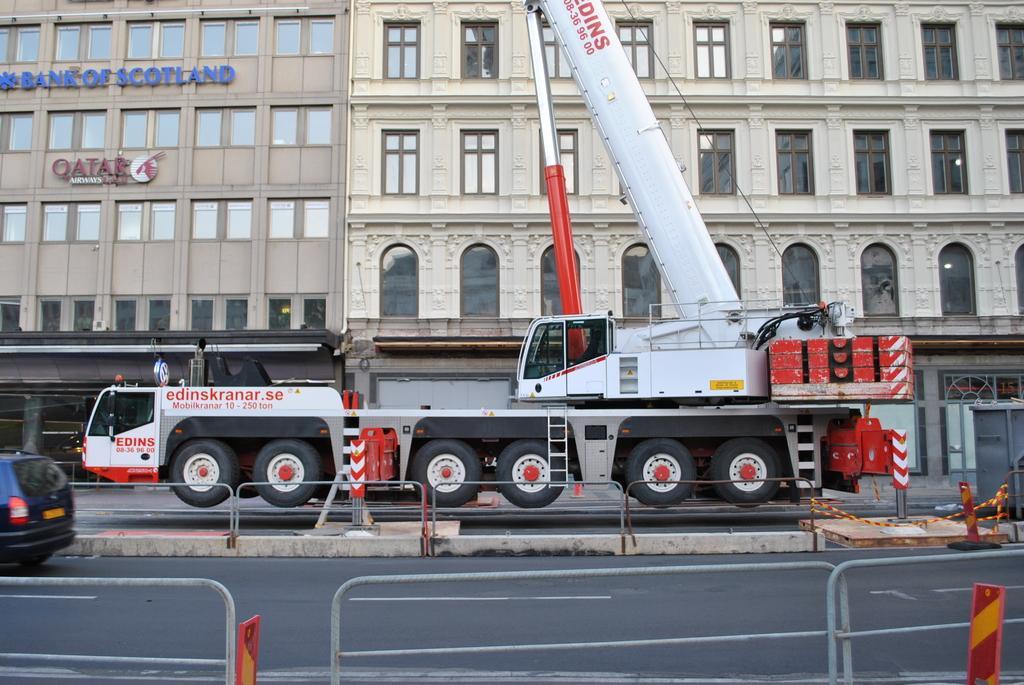Can you describe this image briefly? In this image we can see the vehicles on the road. We can also see the barriers, safety boards and also the buildings in the background. 